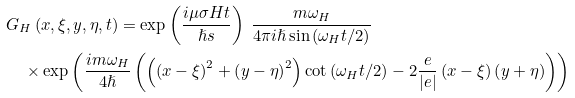Convert formula to latex. <formula><loc_0><loc_0><loc_500><loc_500>& G _ { H } \left ( x , \xi , y , \eta , t \right ) = \exp \left ( \frac { i \mu \sigma H t } { \hslash s } \right ) \ \frac { m \omega _ { H } } { 4 \pi i \hslash \sin \left ( \omega _ { H } t / 2 \right ) } \ \\ & \quad \times \exp \left ( \frac { i m \omega _ { H } } { 4 \hslash } \left ( \left ( \left ( x - \xi \right ) ^ { 2 } + \left ( y - \eta \right ) ^ { 2 } \right ) \cot \left ( \omega _ { H } t / 2 \right ) - 2 \frac { e } { \left | e \right | } \left ( x - \xi \right ) \left ( y + \eta \right ) \right ) \right )</formula> 